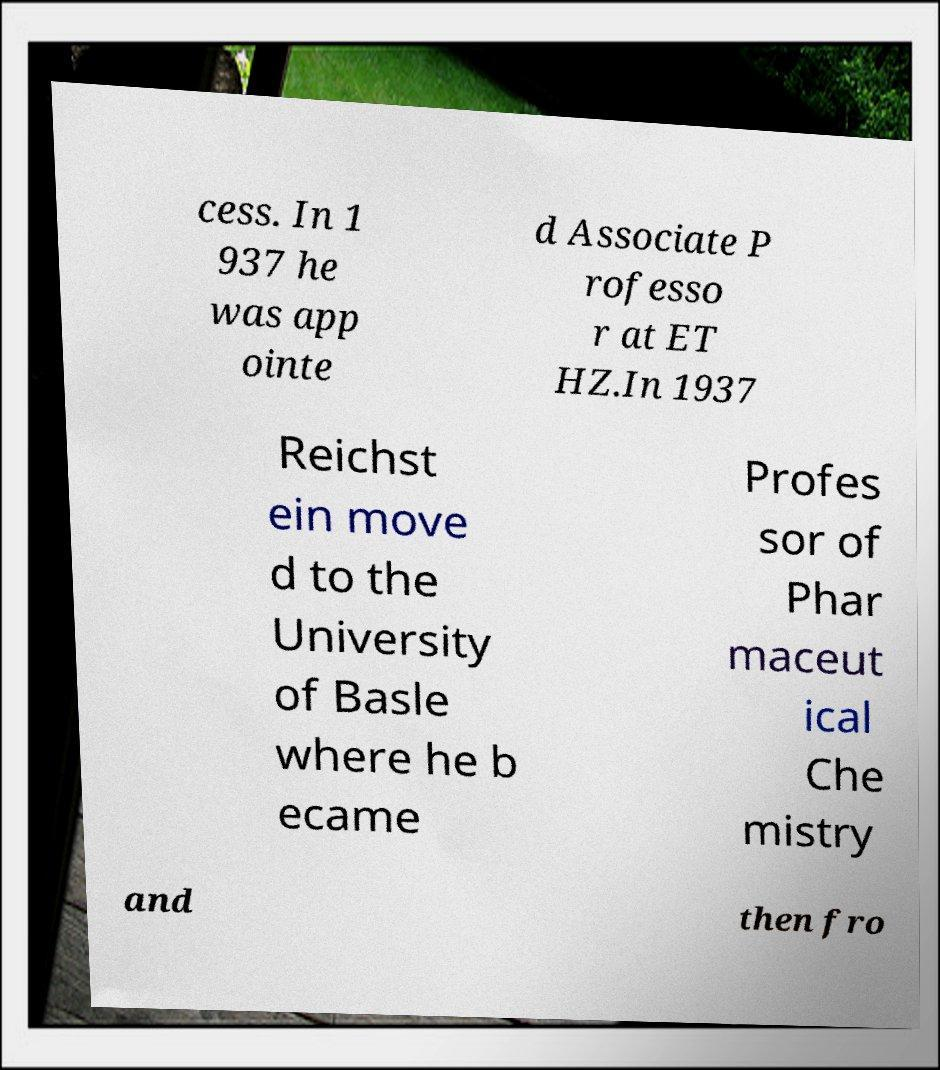For documentation purposes, I need the text within this image transcribed. Could you provide that? cess. In 1 937 he was app ointe d Associate P rofesso r at ET HZ.In 1937 Reichst ein move d to the University of Basle where he b ecame Profes sor of Phar maceut ical Che mistry and then fro 